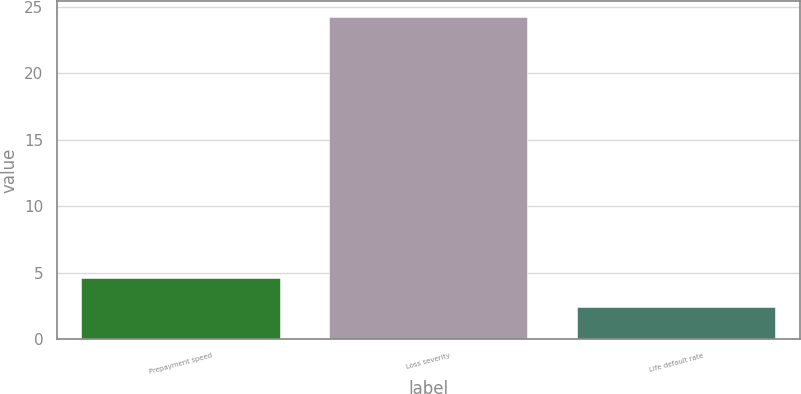Convert chart. <chart><loc_0><loc_0><loc_500><loc_500><bar_chart><fcel>Prepayment speed<fcel>Loss severity<fcel>Life default rate<nl><fcel>4.58<fcel>24.2<fcel>2.4<nl></chart> 